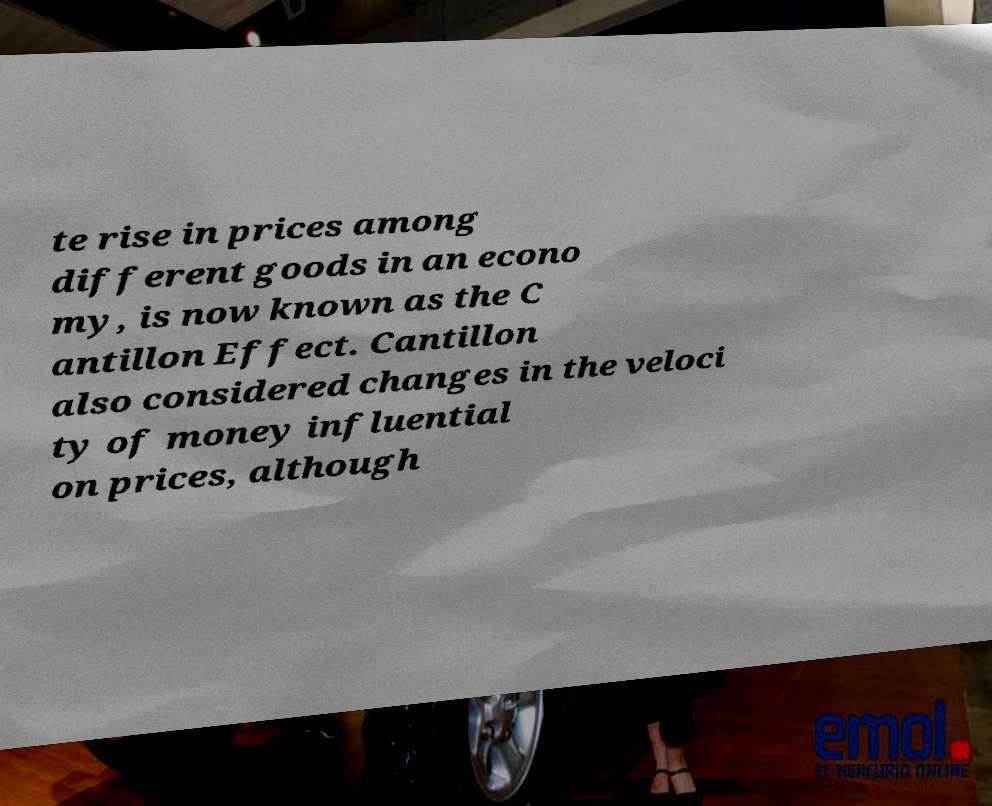Can you accurately transcribe the text from the provided image for me? te rise in prices among different goods in an econo my, is now known as the C antillon Effect. Cantillon also considered changes in the veloci ty of money influential on prices, although 